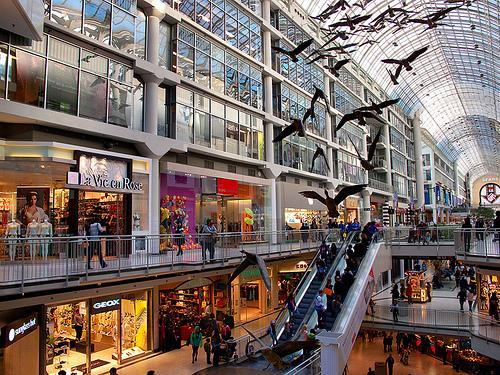What is this type of building called? shopping mall 